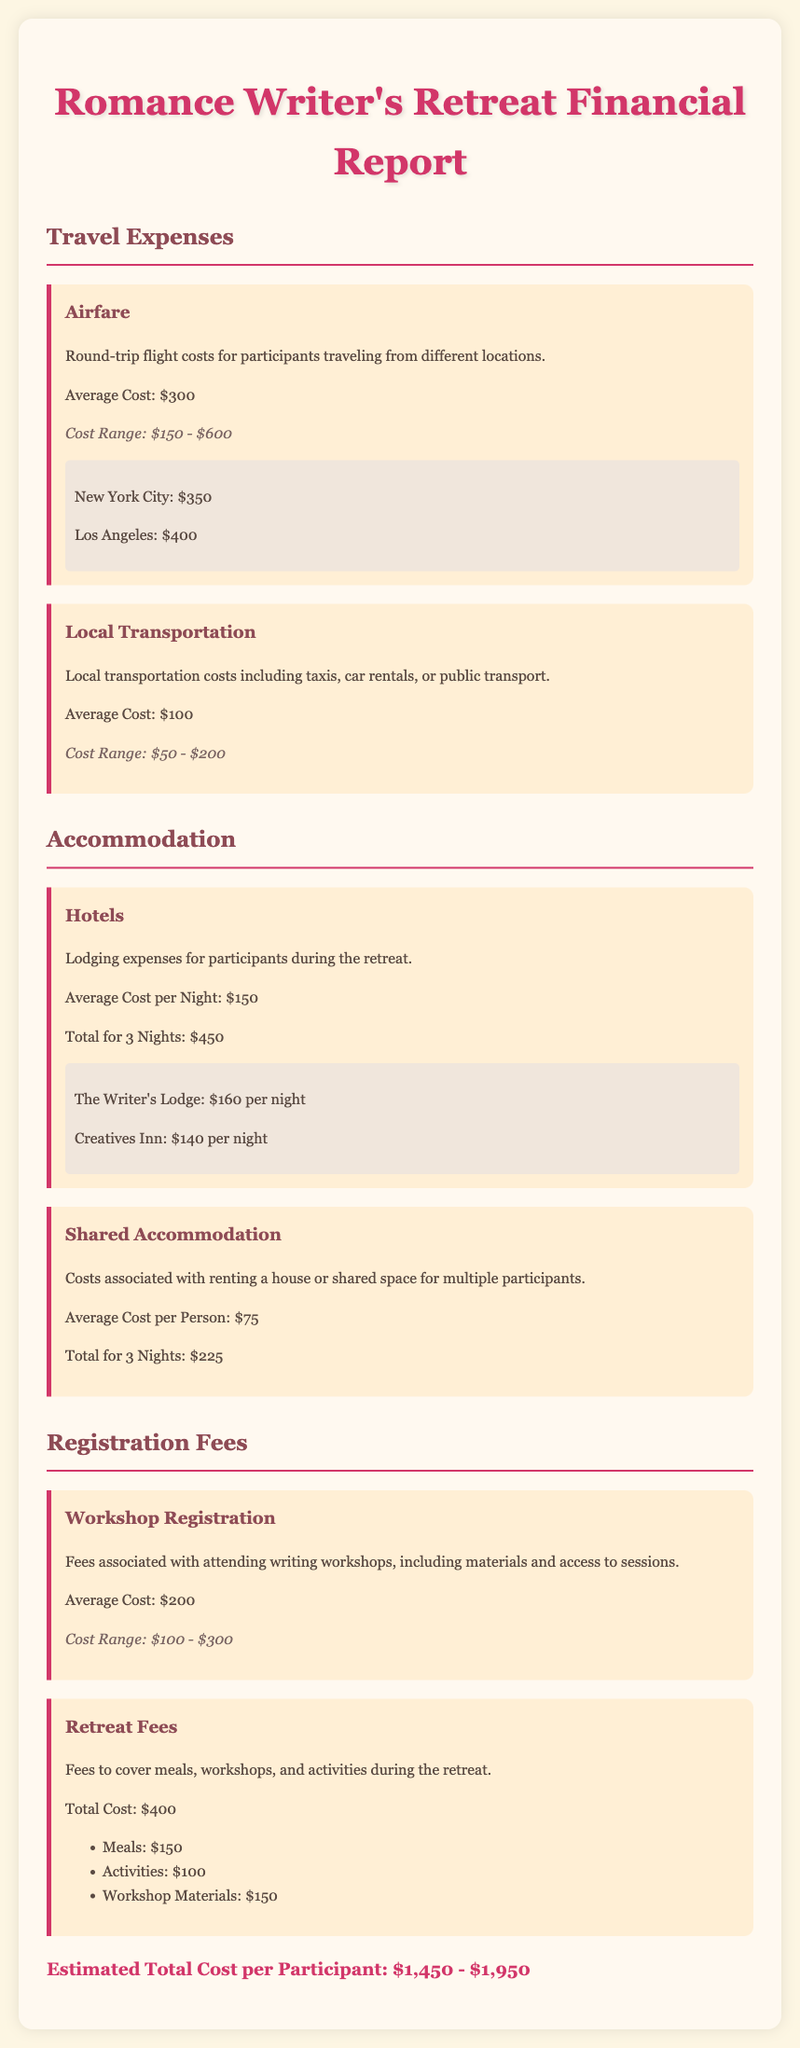what is the average cost of airfare? The average cost of airfare is specified in the travel expenses section of the document.
Answer: $300 what is the total cost for accommodation for 3 nights at a hotel? The total cost for accommodation at a hotel for 3 nights is detailed under the accommodation section.
Answer: $450 what is the cost range for workshop registration? The cost range for workshop registration fees is found in the registration fees section.
Answer: $100 - $300 what is the average cost of shared accommodation per person? The average cost for shared accommodation per person is identified in the accommodation part of the document.
Answer: $75 what is the total estimated cost per participant? The estimated total cost per participant is located at the end of the financial report.
Answer: $1,450 - $1,950 what expenses are included in retreat fees? The retreat fees include multiple components detailed in the registration fees section.
Answer: Meals, Activities, Workshop Materials 